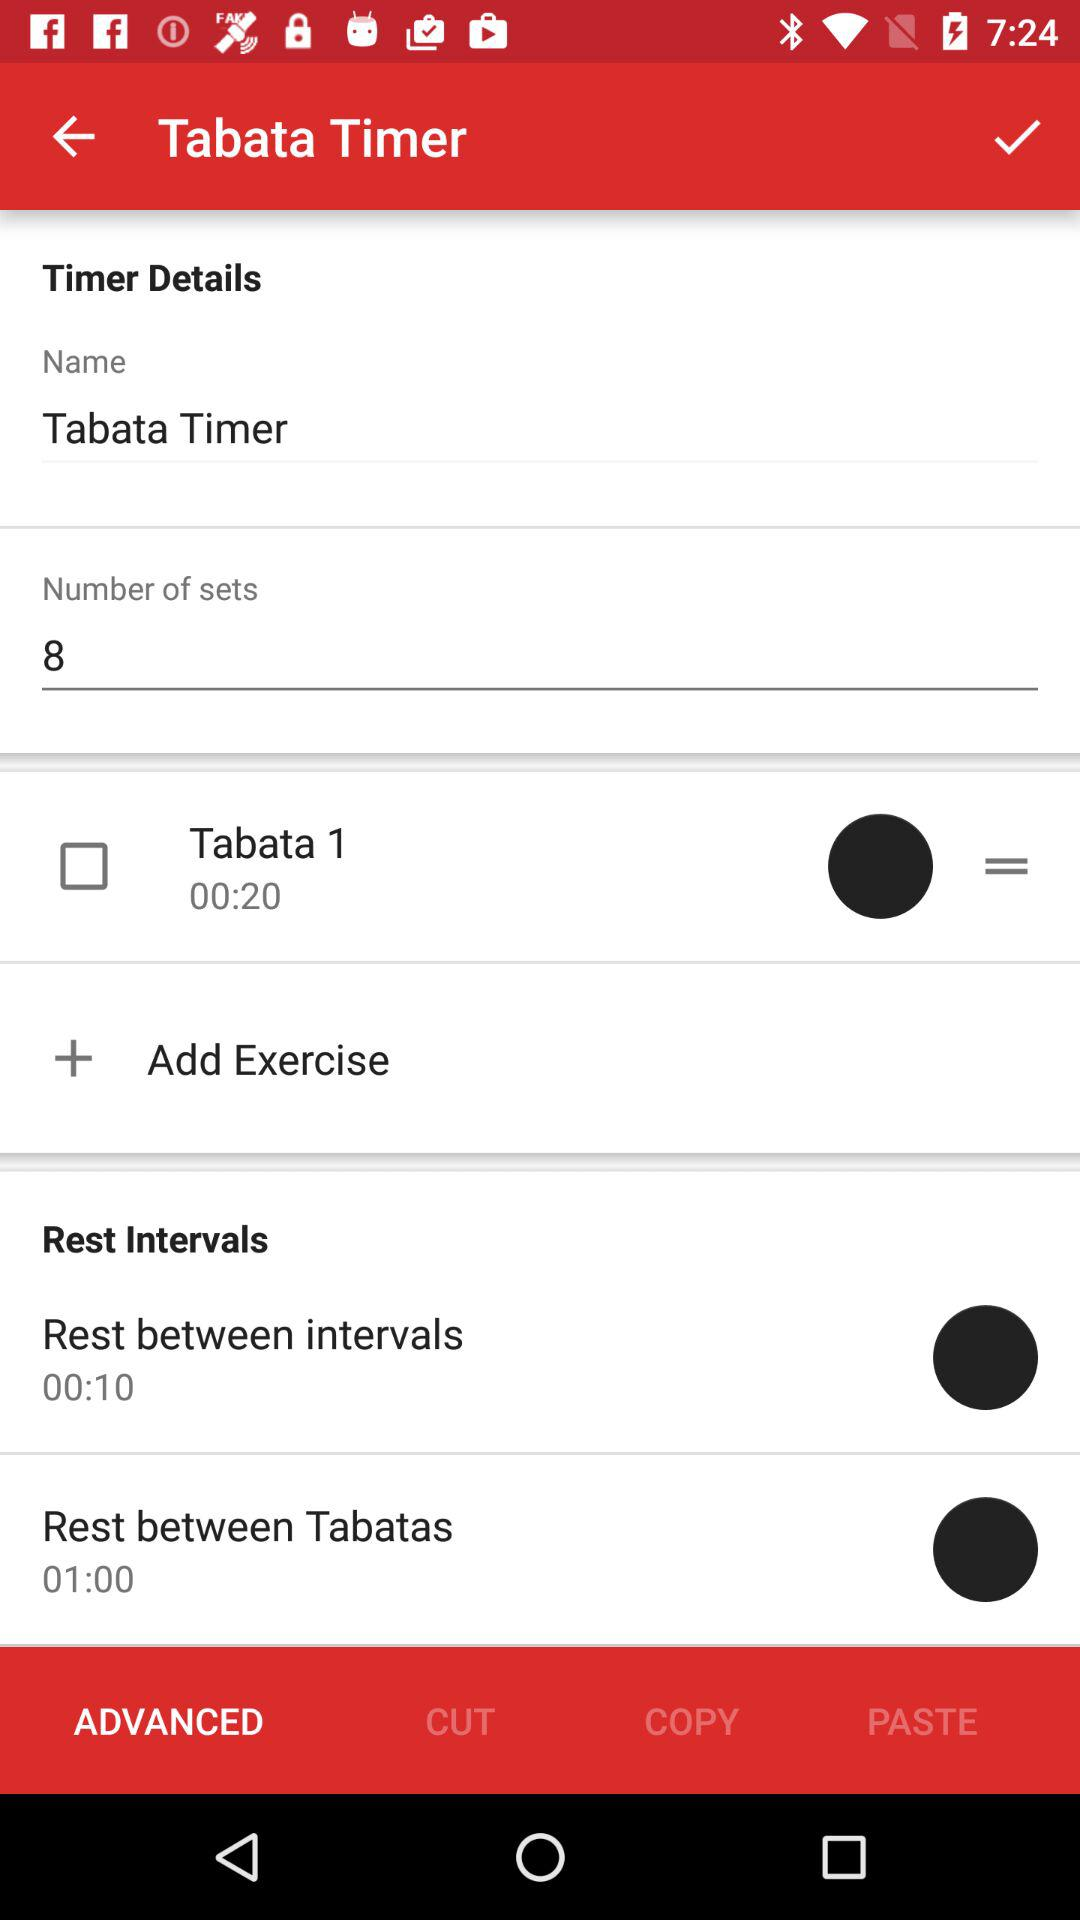What is the rest time between intervals? The rest time between intervals is 10 seconds. 